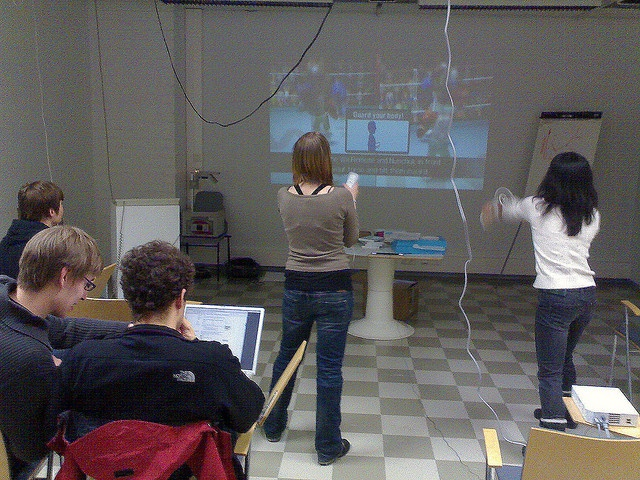Describe the objects in this image and their specific colors. I can see people in gray, black, navy, and maroon tones, people in gray, black, navy, and darkgreen tones, people in gray, black, lightgray, and navy tones, people in gray, black, and navy tones, and chair in gray, maroon, black, and brown tones in this image. 